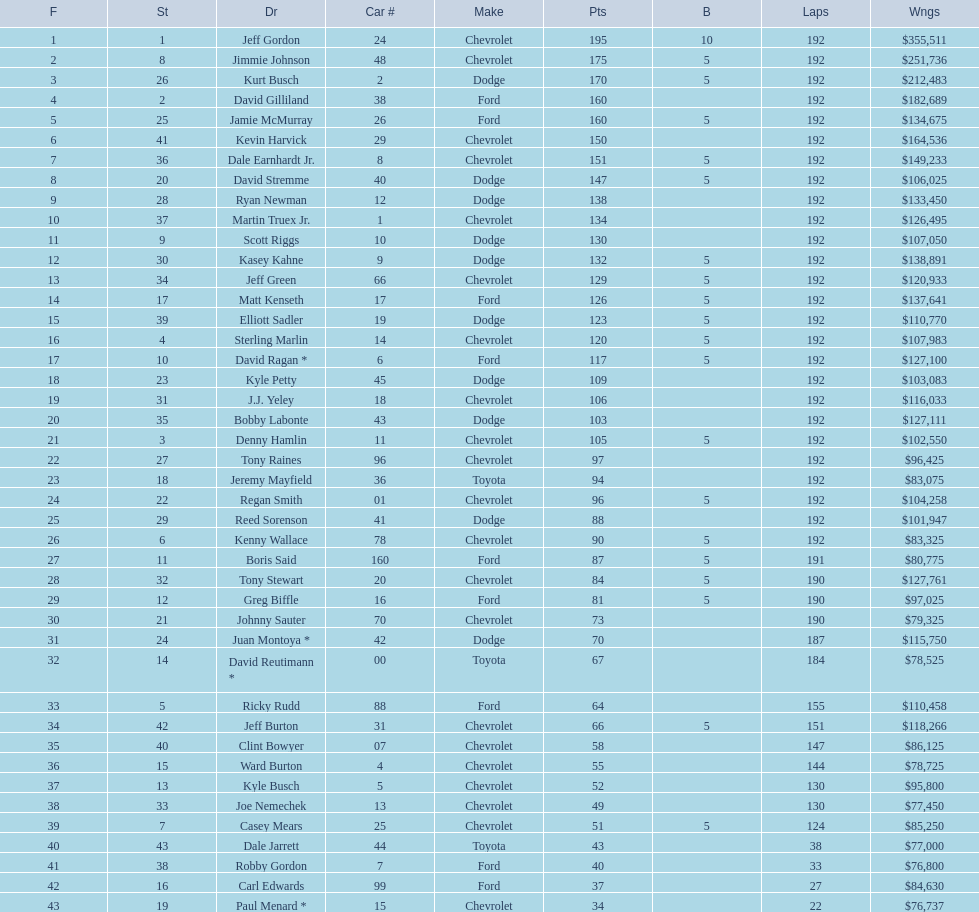How many drivers placed below tony stewart? 15. 